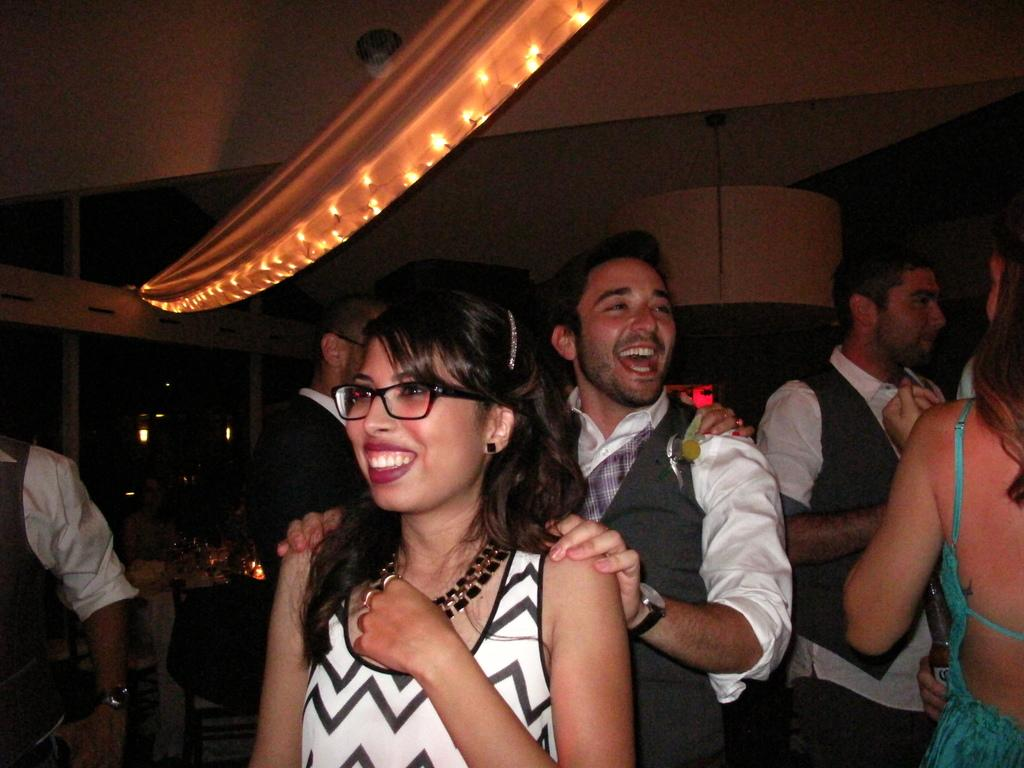Who or what is present in the image? There are people in the image. What is the facial expression of the people in the image? The people have smiling faces. What can be seen at the top of the image? There are lights visible at the top of the image. What type of muscle is being flexed by the people in the image? There is no indication in the image that the people are flexing any muscles. 